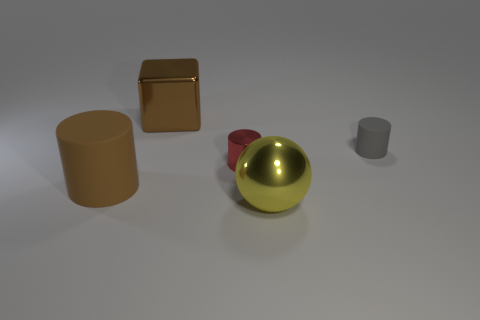Are there more large objects that are behind the big cylinder than things?
Make the answer very short. No. What number of things are either large cylinders or large metallic things that are on the left side of the tiny red metal cylinder?
Your response must be concise. 2. Are there more brown shiny blocks to the right of the gray rubber object than large yellow metal objects to the left of the large brown cylinder?
Provide a succinct answer. No. There is a tiny thing to the right of the big yellow object that is in front of the brown thing that is in front of the tiny rubber thing; what is its material?
Your response must be concise. Rubber. There is a big yellow thing that is the same material as the block; what is its shape?
Your response must be concise. Sphere. There is a brown cylinder that is left of the large yellow thing; are there any large cylinders behind it?
Your response must be concise. No. The yellow metal thing is what size?
Ensure brevity in your answer.  Large. What number of things are either matte cylinders or balls?
Offer a terse response. 3. Does the big thing that is to the left of the large cube have the same material as the big thing in front of the big brown rubber thing?
Offer a terse response. No. There is a thing that is made of the same material as the large cylinder; what color is it?
Your answer should be very brief. Gray. 